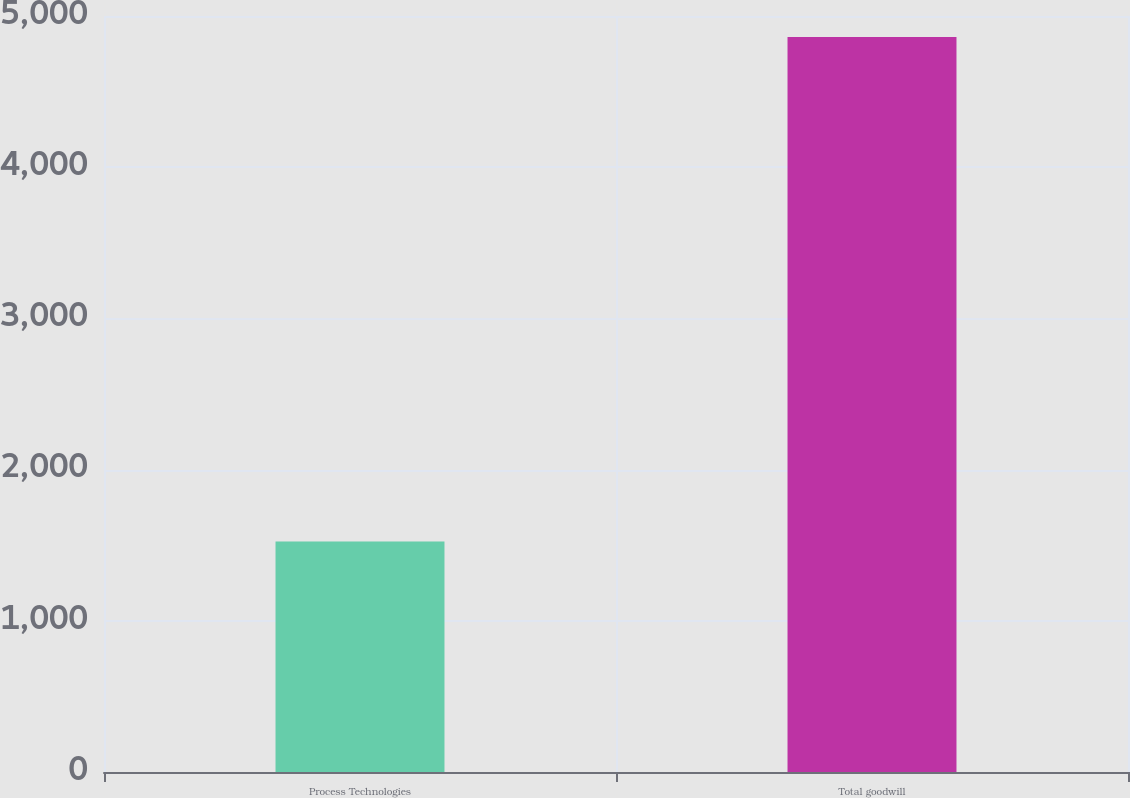Convert chart to OTSL. <chart><loc_0><loc_0><loc_500><loc_500><bar_chart><fcel>Process Technologies<fcel>Total goodwill<nl><fcel>1524.5<fcel>4860.7<nl></chart> 